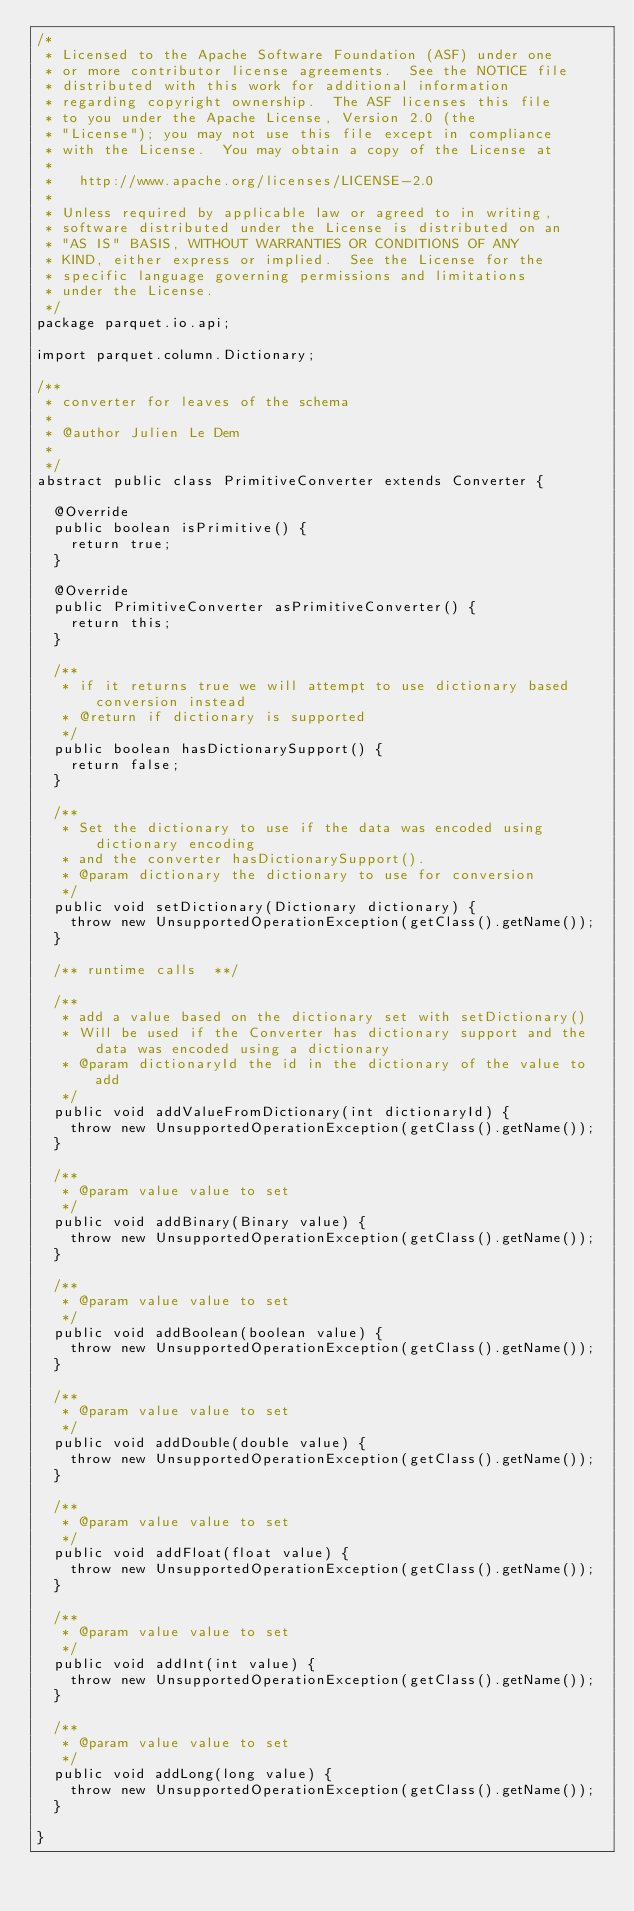<code> <loc_0><loc_0><loc_500><loc_500><_Java_>/* 
 * Licensed to the Apache Software Foundation (ASF) under one
 * or more contributor license agreements.  See the NOTICE file
 * distributed with this work for additional information
 * regarding copyright ownership.  The ASF licenses this file
 * to you under the Apache License, Version 2.0 (the
 * "License"); you may not use this file except in compliance
 * with the License.  You may obtain a copy of the License at
 * 
 *   http://www.apache.org/licenses/LICENSE-2.0
 * 
 * Unless required by applicable law or agreed to in writing,
 * software distributed under the License is distributed on an
 * "AS IS" BASIS, WITHOUT WARRANTIES OR CONDITIONS OF ANY
 * KIND, either express or implied.  See the License for the
 * specific language governing permissions and limitations
 * under the License.
 */
package parquet.io.api;

import parquet.column.Dictionary;

/**
 * converter for leaves of the schema
 *
 * @author Julien Le Dem
 *
 */
abstract public class PrimitiveConverter extends Converter {

  @Override
  public boolean isPrimitive() {
    return true;
  }

  @Override
  public PrimitiveConverter asPrimitiveConverter() {
    return this;
  }

  /**
   * if it returns true we will attempt to use dictionary based conversion instead
   * @return if dictionary is supported
   */
  public boolean hasDictionarySupport() {
    return false;
  }

  /**
   * Set the dictionary to use if the data was encoded using dictionary encoding
   * and the converter hasDictionarySupport().
   * @param dictionary the dictionary to use for conversion
   */
  public void setDictionary(Dictionary dictionary) {
    throw new UnsupportedOperationException(getClass().getName());
  }

  /** runtime calls  **/

  /**
   * add a value based on the dictionary set with setDictionary()
   * Will be used if the Converter has dictionary support and the data was encoded using a dictionary
   * @param dictionaryId the id in the dictionary of the value to add
   */
  public void addValueFromDictionary(int dictionaryId) {
    throw new UnsupportedOperationException(getClass().getName());
  }

  /**
   * @param value value to set
   */
  public void addBinary(Binary value) {
    throw new UnsupportedOperationException(getClass().getName());
  }

  /**
   * @param value value to set
   */
  public void addBoolean(boolean value) {
    throw new UnsupportedOperationException(getClass().getName());
  }

  /**
   * @param value value to set
   */
  public void addDouble(double value) {
    throw new UnsupportedOperationException(getClass().getName());
  }

  /**
   * @param value value to set
   */
  public void addFloat(float value) {
    throw new UnsupportedOperationException(getClass().getName());
  }

  /**
   * @param value value to set
   */
  public void addInt(int value) {
    throw new UnsupportedOperationException(getClass().getName());
  }

  /**
   * @param value value to set
   */
  public void addLong(long value) {
    throw new UnsupportedOperationException(getClass().getName());
  }

}
</code> 